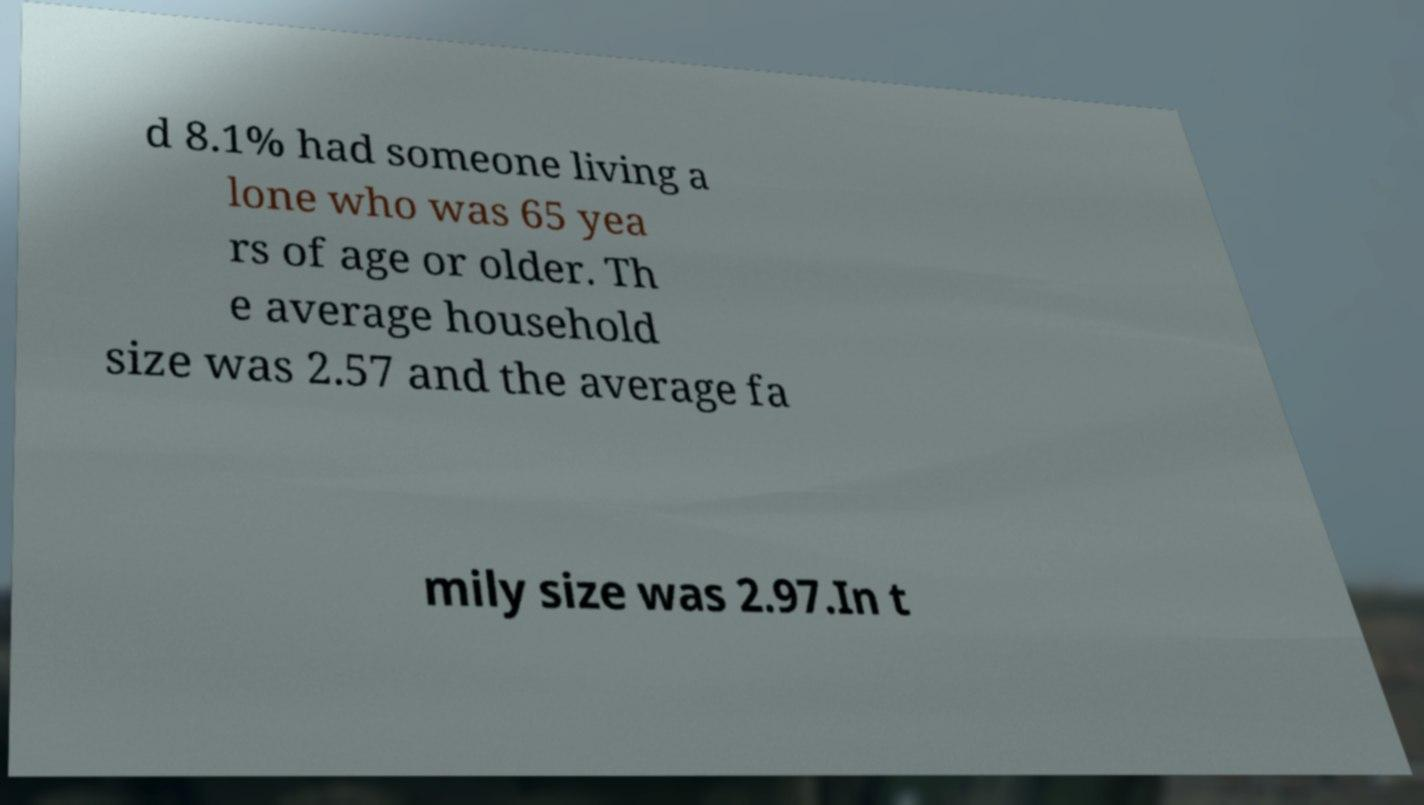Could you assist in decoding the text presented in this image and type it out clearly? d 8.1% had someone living a lone who was 65 yea rs of age or older. Th e average household size was 2.57 and the average fa mily size was 2.97.In t 